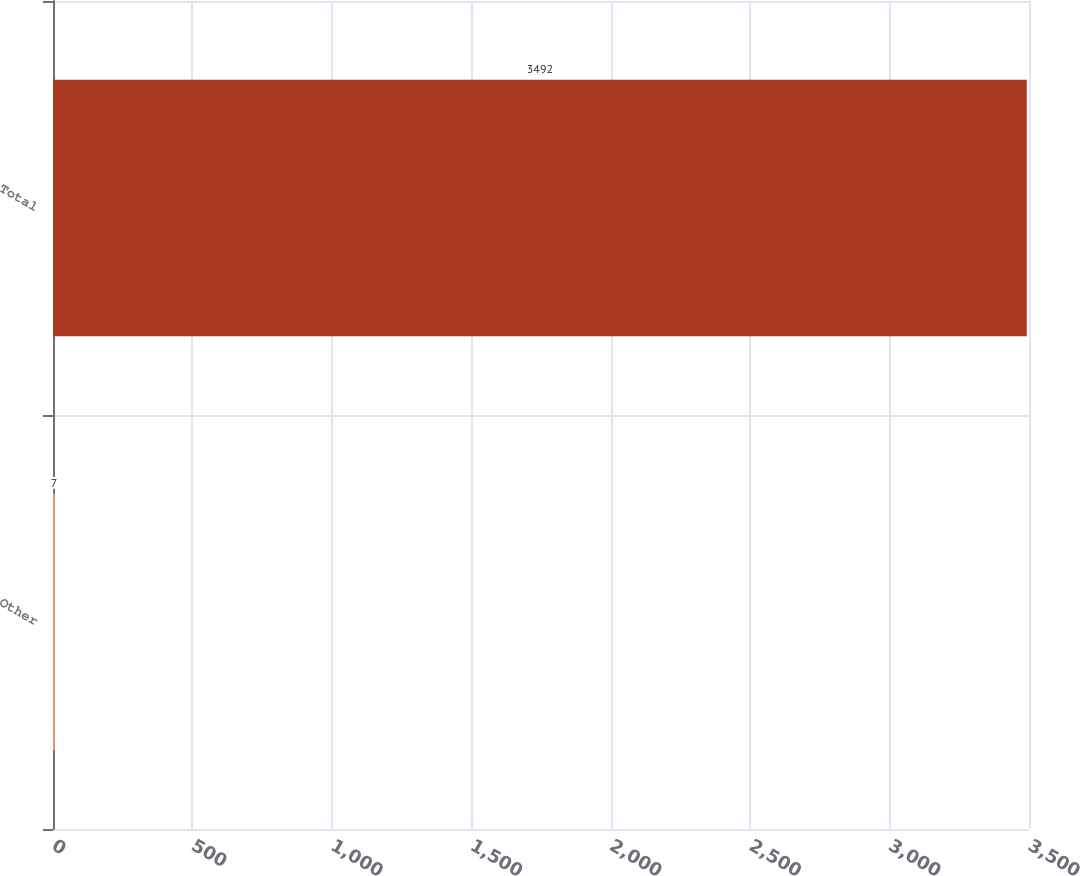Convert chart to OTSL. <chart><loc_0><loc_0><loc_500><loc_500><bar_chart><fcel>Other<fcel>Total<nl><fcel>7<fcel>3492<nl></chart> 